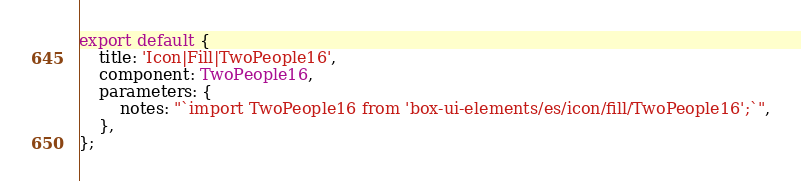<code> <loc_0><loc_0><loc_500><loc_500><_TypeScript_>
export default {
    title: 'Icon|Fill|TwoPeople16',
    component: TwoPeople16,
    parameters: {
        notes: "`import TwoPeople16 from 'box-ui-elements/es/icon/fill/TwoPeople16';`",
    },
};
</code> 